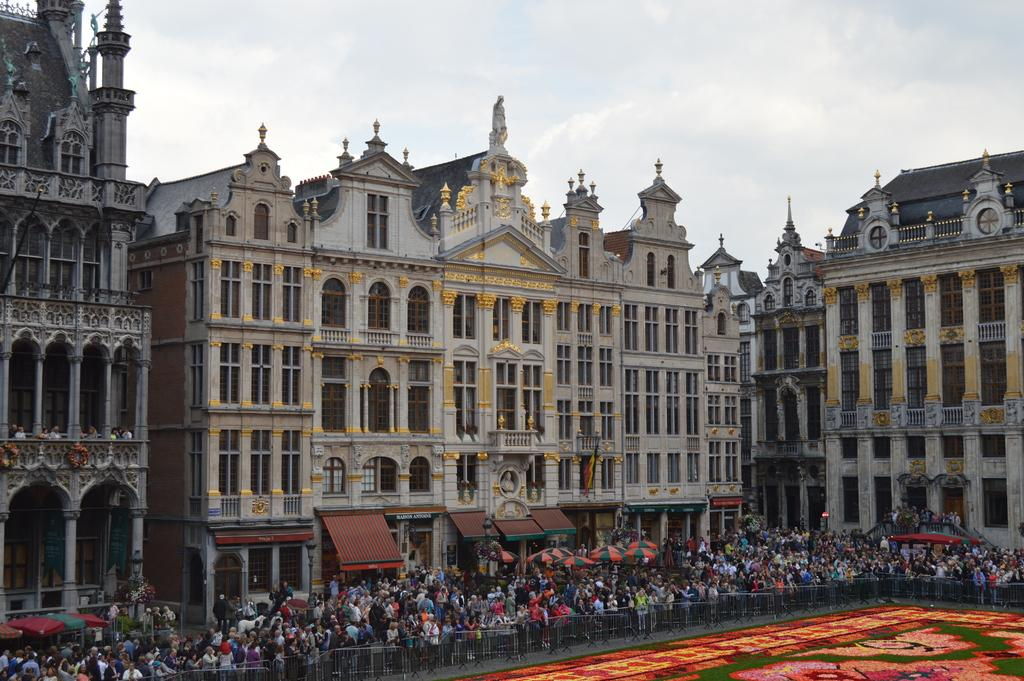What can be seen in the image in terms of people and structures? There are many people in front of buildings in the image. What objects are present that might be used for crowd control or safety? There are barricades in the image. What type of flooring is visible in the image? There is a carpet in the image. What objects are being used to provide shade or protection from the elements? There are umbrellas in front of the buildings. How would you describe the weather based on the image? The sky is clear in the image, suggesting good weather. How many friends are sitting on the turkey in the image? There is no turkey present in the image, and therefore no friends can be seen sitting on it. 